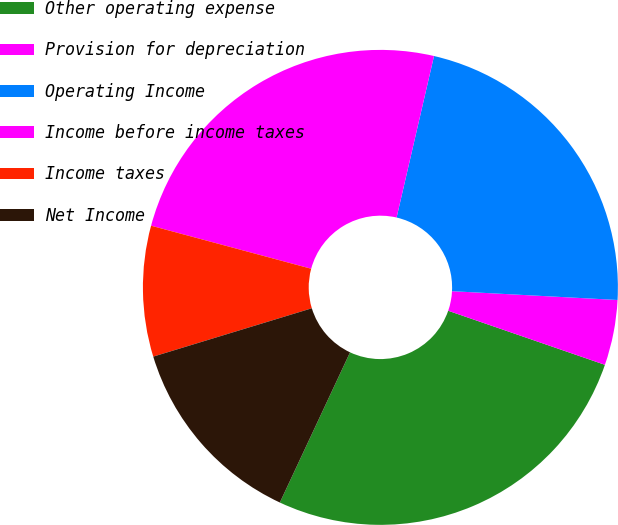Convert chart to OTSL. <chart><loc_0><loc_0><loc_500><loc_500><pie_chart><fcel>Other operating expense<fcel>Provision for depreciation<fcel>Operating Income<fcel>Income before income taxes<fcel>Income taxes<fcel>Net Income<nl><fcel>26.67%<fcel>4.44%<fcel>22.22%<fcel>24.44%<fcel>8.89%<fcel>13.33%<nl></chart> 